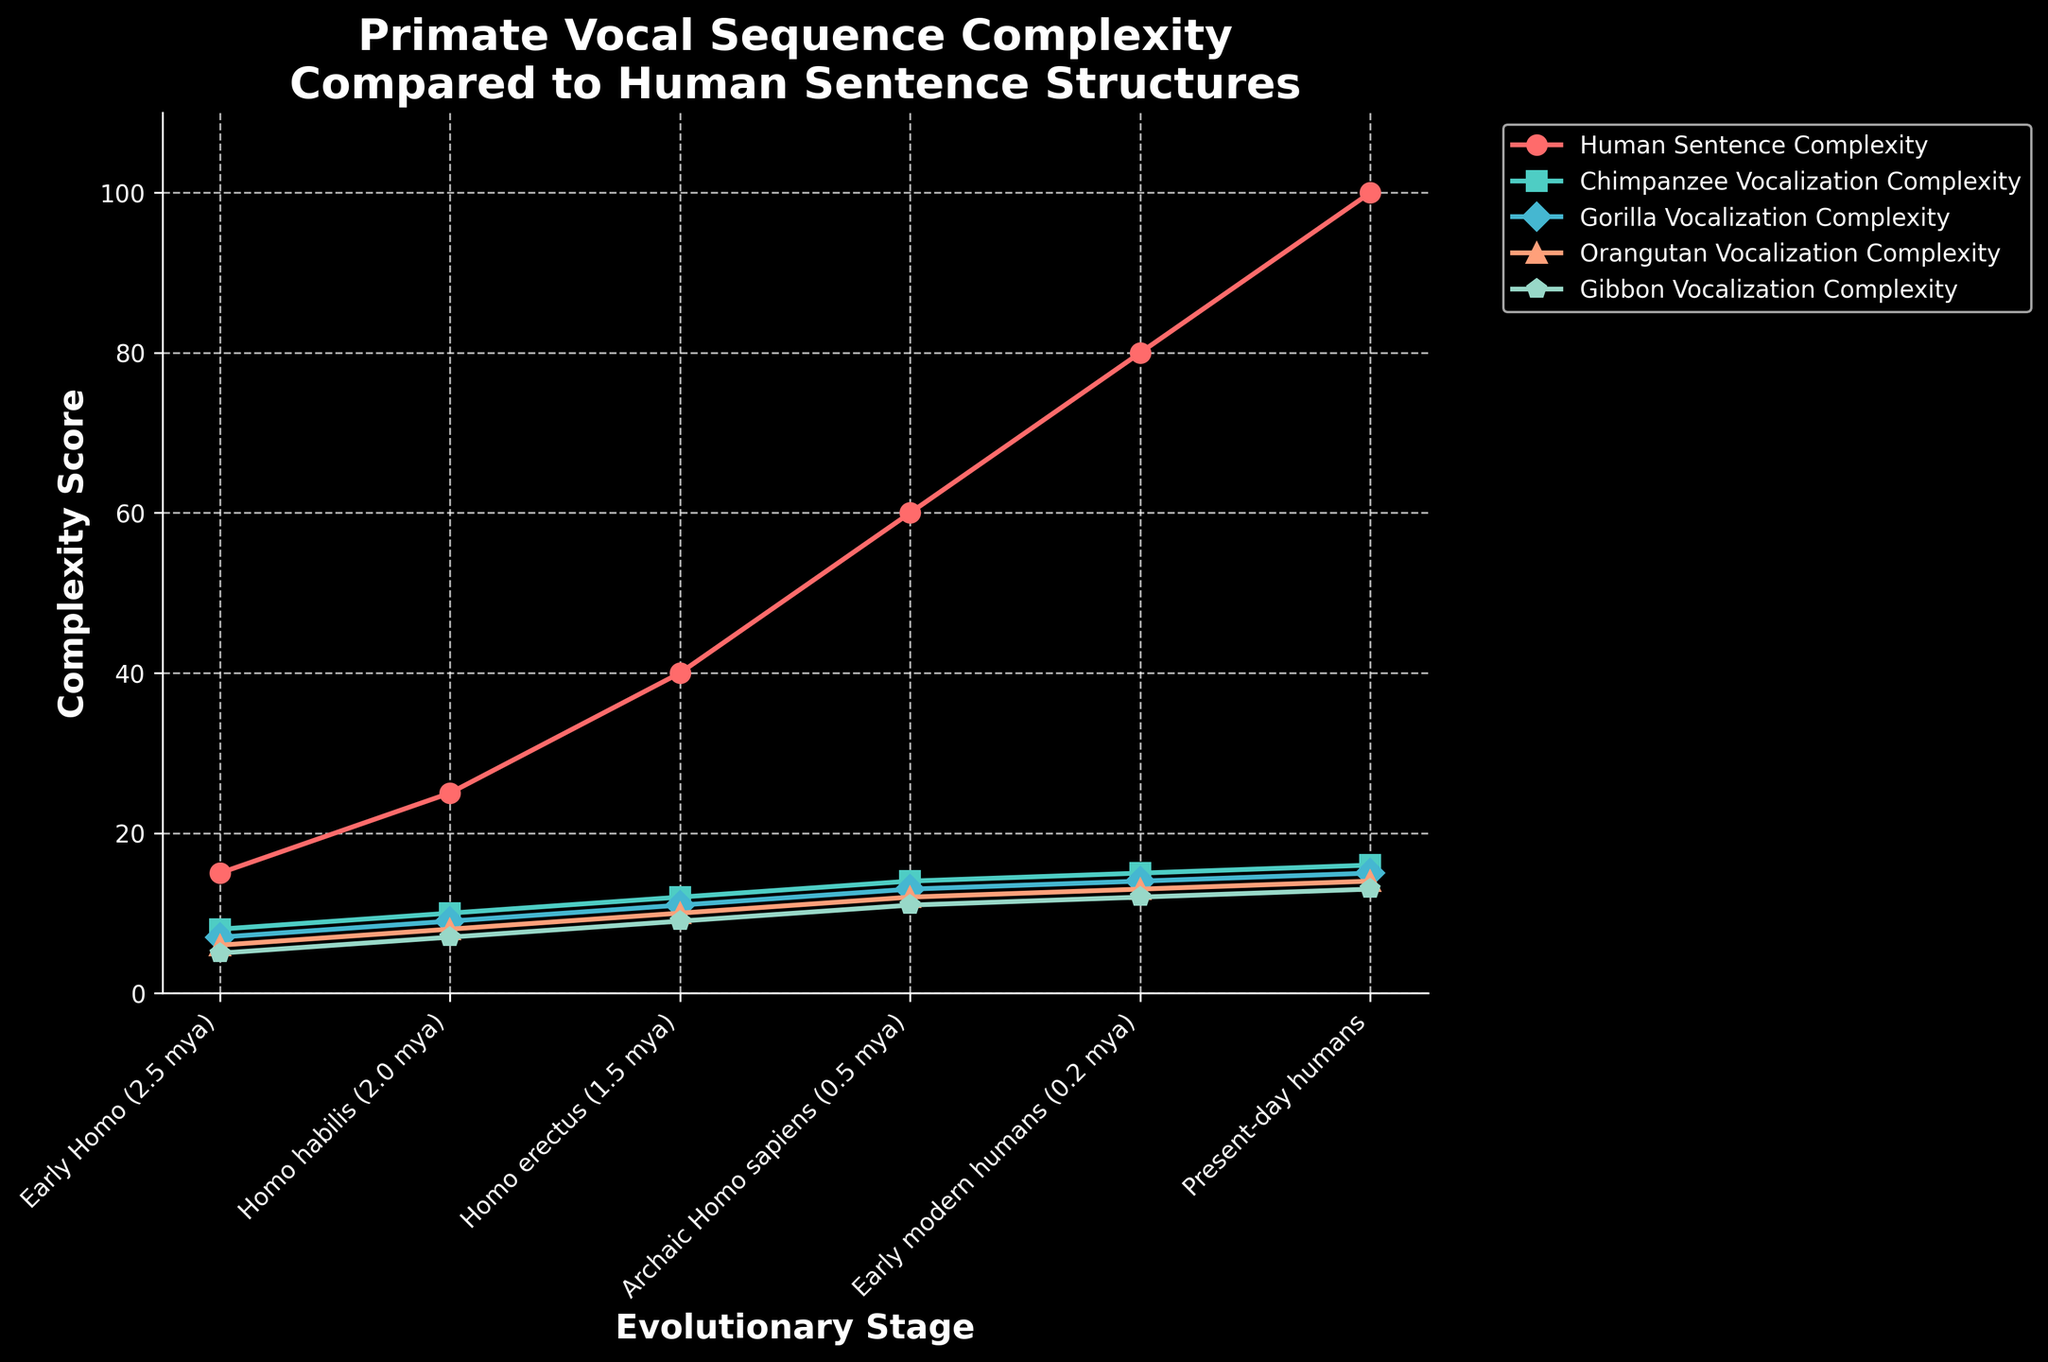What's the trend for human sentence complexity across evolutionary stages? Human sentence complexity consistently increases from Early Homo to Present-day humans. The complexity scores at the given stages are: Early Homo (15), Homo habilis (25), Homo erectus (40), Archaic Homo sapiens (60), Early modern humans (80), and Present-day humans (100).
Answer: It increases Which primate species has the lowest vocalization complexity in Homo erectus? In the Homo erectus stage, the gibbon has the lowest vocalization complexity score, which is 9.
Answer: Gibbon How does the complexity score of chimpanzee vocalizations compare between Homo habilis and Present-day humans? The chimpanzee vocalization complexity score is 10 at Homo habilis and increases to 16 at Present-day humans.
Answer: It increases Between gibbon and gorilla vocalization complexities, which evolves more rapidly from Early Homo to Present-day humans? The gibbon vocalization complexity increases from 5 to 13 (an increase of 8), while the gorilla's complexity increases from 7 to 15 (an increase of 8). Both evolve at the same rate.
Answer: They evolve at the same rate What is the difference in complexity scores between orangutan and gibbon vocalizations in Archaic Homo sapiens? In Archaic Homo sapiens, the orangutan has a complexity score of 12 and the gibbon has a score of 11. The difference is 12 - 11 = 1.
Answer: 1 What is the average complexity score of human sentence structures over the evolutionary stages plotted? The complexity scores for human sentence structures are 15, 25, 40, 60, 80, and 100. The sum is 320 and the average is 320 / 6 = 53.33.
Answer: 53.33 Which evolutionary stage shows the highest difference between human sentence complexity and chimpanzee vocalization complexity? The differences between human and chimpanzee complexities are: Early Homo (7), Homo habilis (15), Homo erectus (28), Archaic Homo sapiens (46), Early modern humans (65), Present-day humans (84). The highest difference is at Present-day humans with a difference of 84.
Answer: Present-day humans At which evolutionary stage do orangutans and gorillas have equal vocalization complexities? At Homo habilis, the vocalization complexities for both orangutans and gorillas are equal at 9.
Answer: Homo habilis What is the trend of gibbon vocalization complexity scores over the evolutionary stages? The scores for gibbon vocalization complexity increase consistently from Early Homo (5), Homo habilis (7), Homo erectus (9), Archaic Homo sapiens (11), Early modern humans (12), to Present-day humans (13).
Answer: It increases 